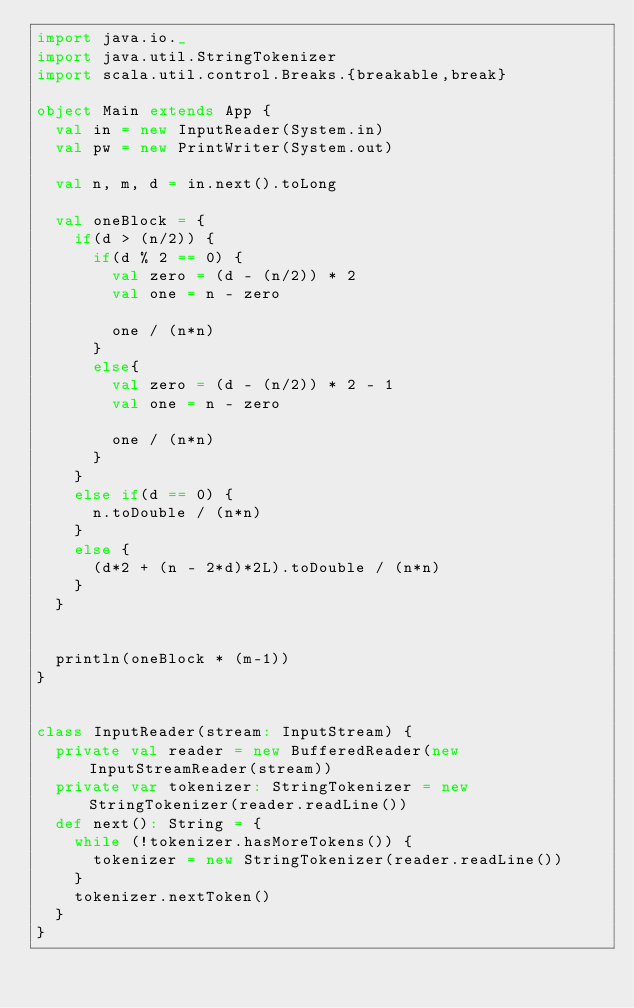<code> <loc_0><loc_0><loc_500><loc_500><_Scala_>import java.io._
import java.util.StringTokenizer
import scala.util.control.Breaks.{breakable,break}

object Main extends App {
  val in = new InputReader(System.in)
  val pw = new PrintWriter(System.out)

  val n, m, d = in.next().toLong

  val oneBlock = {
    if(d > (n/2)) {
      if(d % 2 == 0) {
        val zero = (d - (n/2)) * 2
        val one = n - zero

        one / (n*n)
      }
      else{
        val zero = (d - (n/2)) * 2 - 1
        val one = n - zero

        one / (n*n)
      }
    }
    else if(d == 0) {
      n.toDouble / (n*n)
    }
    else {
      (d*2 + (n - 2*d)*2L).toDouble / (n*n)
    }
  }


  println(oneBlock * (m-1))
}


class InputReader(stream: InputStream) {
  private val reader = new BufferedReader(new InputStreamReader(stream))
  private var tokenizer: StringTokenizer = new StringTokenizer(reader.readLine())
  def next(): String = {
    while (!tokenizer.hasMoreTokens()) {
      tokenizer = new StringTokenizer(reader.readLine())
    }
    tokenizer.nextToken()
  }
}

</code> 